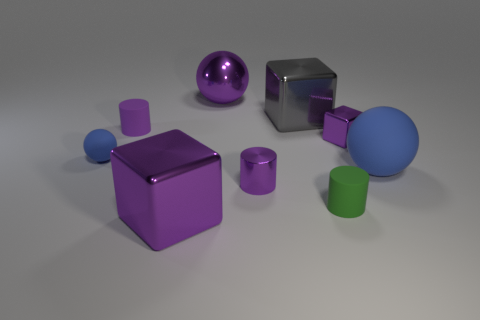What purpose could these objects serve if they were in a real-world setting? In a real-world setting, these objects could serve various decorative or functional purposes. The cubes, for example, could be furniture pieces like side tables or stools, while the spheres might be used as ornaments or paperweights. The cylindrical shapes might find use as containers or trendy architectural elements. 